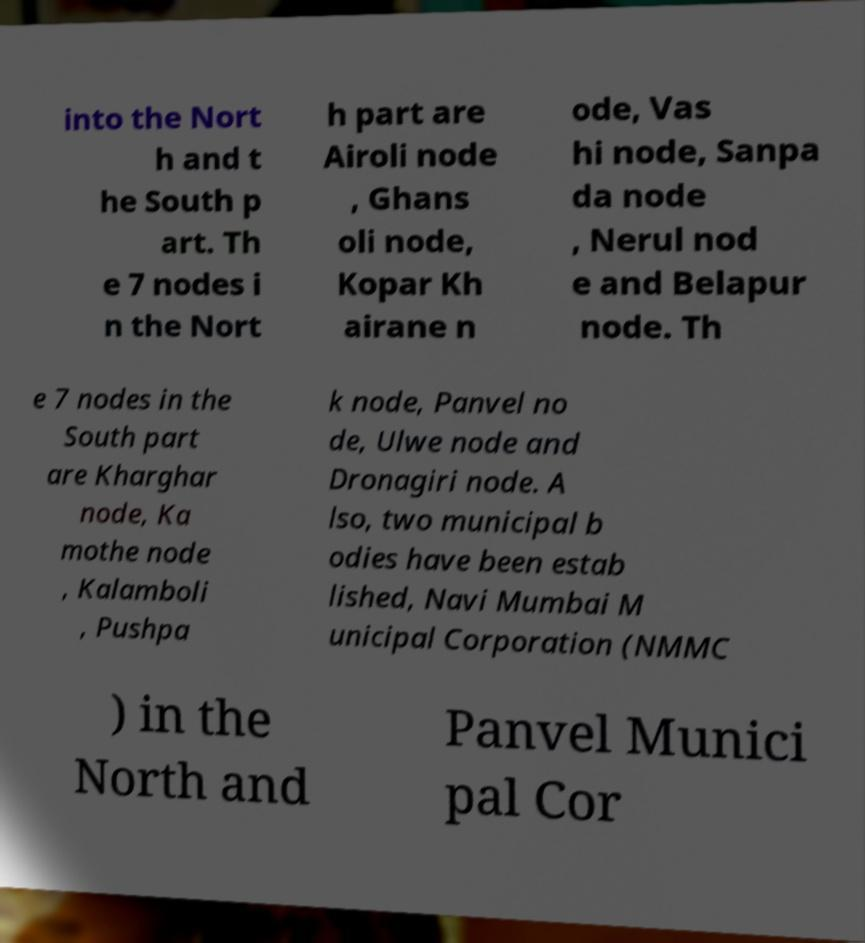I need the written content from this picture converted into text. Can you do that? into the Nort h and t he South p art. Th e 7 nodes i n the Nort h part are Airoli node , Ghans oli node, Kopar Kh airane n ode, Vas hi node, Sanpa da node , Nerul nod e and Belapur node. Th e 7 nodes in the South part are Kharghar node, Ka mothe node , Kalamboli , Pushpa k node, Panvel no de, Ulwe node and Dronagiri node. A lso, two municipal b odies have been estab lished, Navi Mumbai M unicipal Corporation (NMMC ) in the North and Panvel Munici pal Cor 